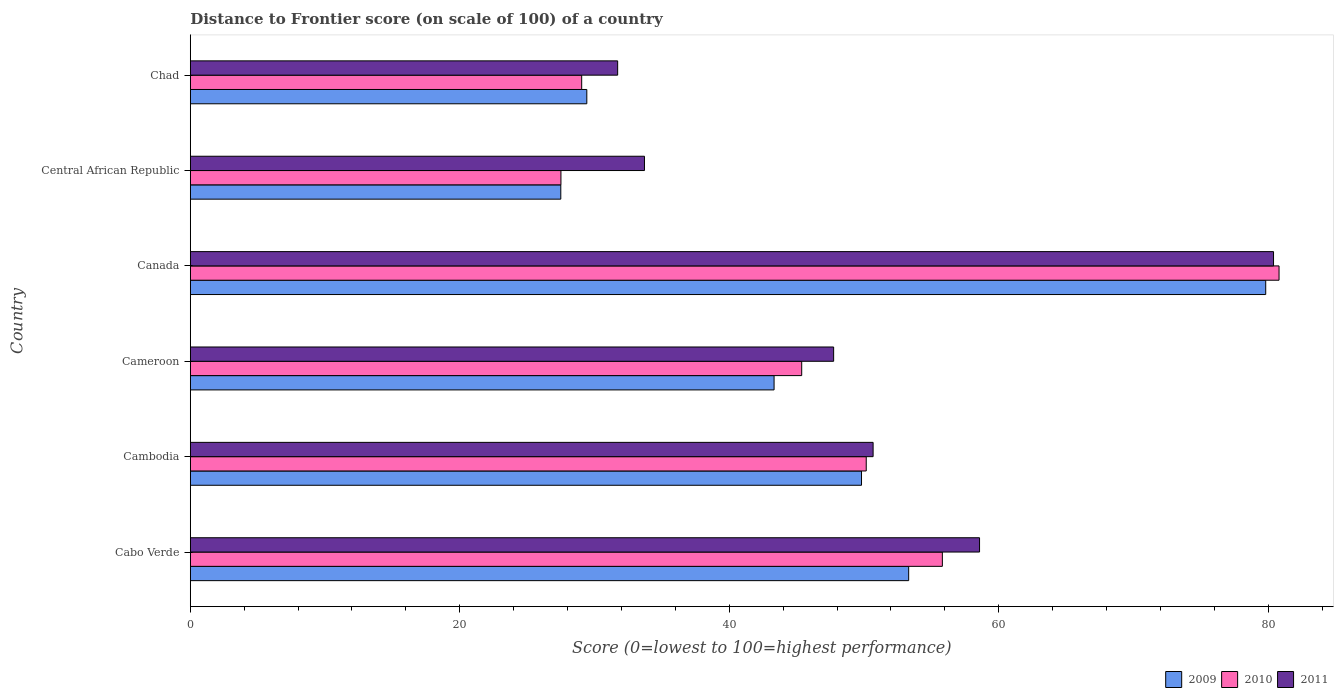How many different coloured bars are there?
Provide a short and direct response. 3. Are the number of bars per tick equal to the number of legend labels?
Give a very brief answer. Yes. How many bars are there on the 1st tick from the top?
Your answer should be compact. 3. How many bars are there on the 4th tick from the bottom?
Your response must be concise. 3. What is the label of the 6th group of bars from the top?
Your response must be concise. Cabo Verde. What is the distance to frontier score of in 2010 in Canada?
Your answer should be very brief. 80.81. Across all countries, what is the maximum distance to frontier score of in 2009?
Make the answer very short. 79.82. In which country was the distance to frontier score of in 2010 minimum?
Offer a terse response. Central African Republic. What is the total distance to frontier score of in 2011 in the graph?
Make the answer very short. 302.84. What is the difference between the distance to frontier score of in 2010 in Canada and that in Central African Republic?
Your response must be concise. 53.3. What is the difference between the distance to frontier score of in 2011 in Canada and the distance to frontier score of in 2010 in Chad?
Offer a very short reply. 51.35. What is the average distance to frontier score of in 2010 per country?
Give a very brief answer. 48.12. What is the difference between the distance to frontier score of in 2011 and distance to frontier score of in 2010 in Canada?
Offer a terse response. -0.41. What is the ratio of the distance to frontier score of in 2011 in Cameroon to that in Canada?
Offer a very short reply. 0.59. Is the distance to frontier score of in 2010 in Canada less than that in Central African Republic?
Keep it short and to the point. No. Is the difference between the distance to frontier score of in 2011 in Cabo Verde and Central African Republic greater than the difference between the distance to frontier score of in 2010 in Cabo Verde and Central African Republic?
Offer a very short reply. No. What is the difference between the highest and the second highest distance to frontier score of in 2011?
Your answer should be compact. 21.82. What is the difference between the highest and the lowest distance to frontier score of in 2010?
Ensure brevity in your answer.  53.3. What does the 3rd bar from the bottom in Canada represents?
Offer a terse response. 2011. Is it the case that in every country, the sum of the distance to frontier score of in 2011 and distance to frontier score of in 2009 is greater than the distance to frontier score of in 2010?
Your response must be concise. Yes. Does the graph contain grids?
Your answer should be very brief. No. Where does the legend appear in the graph?
Your answer should be very brief. Bottom right. What is the title of the graph?
Offer a very short reply. Distance to Frontier score (on scale of 100) of a country. Does "2005" appear as one of the legend labels in the graph?
Your answer should be very brief. No. What is the label or title of the X-axis?
Your response must be concise. Score (0=lowest to 100=highest performance). What is the label or title of the Y-axis?
Your response must be concise. Country. What is the Score (0=lowest to 100=highest performance) in 2009 in Cabo Verde?
Your answer should be compact. 53.32. What is the Score (0=lowest to 100=highest performance) of 2010 in Cabo Verde?
Provide a succinct answer. 55.82. What is the Score (0=lowest to 100=highest performance) of 2011 in Cabo Verde?
Provide a succinct answer. 58.58. What is the Score (0=lowest to 100=highest performance) of 2009 in Cambodia?
Offer a terse response. 49.82. What is the Score (0=lowest to 100=highest performance) of 2010 in Cambodia?
Your answer should be compact. 50.17. What is the Score (0=lowest to 100=highest performance) in 2011 in Cambodia?
Your answer should be very brief. 50.68. What is the Score (0=lowest to 100=highest performance) in 2009 in Cameroon?
Ensure brevity in your answer.  43.33. What is the Score (0=lowest to 100=highest performance) in 2010 in Cameroon?
Offer a very short reply. 45.38. What is the Score (0=lowest to 100=highest performance) in 2011 in Cameroon?
Provide a short and direct response. 47.75. What is the Score (0=lowest to 100=highest performance) of 2009 in Canada?
Your answer should be compact. 79.82. What is the Score (0=lowest to 100=highest performance) in 2010 in Canada?
Your response must be concise. 80.81. What is the Score (0=lowest to 100=highest performance) of 2011 in Canada?
Your answer should be compact. 80.4. What is the Score (0=lowest to 100=highest performance) of 2010 in Central African Republic?
Offer a terse response. 27.51. What is the Score (0=lowest to 100=highest performance) of 2011 in Central African Republic?
Ensure brevity in your answer.  33.71. What is the Score (0=lowest to 100=highest performance) of 2009 in Chad?
Your answer should be very brief. 29.43. What is the Score (0=lowest to 100=highest performance) of 2010 in Chad?
Offer a terse response. 29.05. What is the Score (0=lowest to 100=highest performance) in 2011 in Chad?
Ensure brevity in your answer.  31.72. Across all countries, what is the maximum Score (0=lowest to 100=highest performance) of 2009?
Your answer should be very brief. 79.82. Across all countries, what is the maximum Score (0=lowest to 100=highest performance) of 2010?
Provide a succinct answer. 80.81. Across all countries, what is the maximum Score (0=lowest to 100=highest performance) in 2011?
Provide a succinct answer. 80.4. Across all countries, what is the minimum Score (0=lowest to 100=highest performance) in 2009?
Provide a succinct answer. 27.5. Across all countries, what is the minimum Score (0=lowest to 100=highest performance) of 2010?
Make the answer very short. 27.51. Across all countries, what is the minimum Score (0=lowest to 100=highest performance) of 2011?
Provide a succinct answer. 31.72. What is the total Score (0=lowest to 100=highest performance) of 2009 in the graph?
Give a very brief answer. 283.22. What is the total Score (0=lowest to 100=highest performance) in 2010 in the graph?
Keep it short and to the point. 288.74. What is the total Score (0=lowest to 100=highest performance) of 2011 in the graph?
Your answer should be very brief. 302.84. What is the difference between the Score (0=lowest to 100=highest performance) in 2010 in Cabo Verde and that in Cambodia?
Your answer should be very brief. 5.65. What is the difference between the Score (0=lowest to 100=highest performance) of 2011 in Cabo Verde and that in Cambodia?
Provide a short and direct response. 7.9. What is the difference between the Score (0=lowest to 100=highest performance) of 2009 in Cabo Verde and that in Cameroon?
Your answer should be very brief. 9.99. What is the difference between the Score (0=lowest to 100=highest performance) in 2010 in Cabo Verde and that in Cameroon?
Your answer should be compact. 10.44. What is the difference between the Score (0=lowest to 100=highest performance) in 2011 in Cabo Verde and that in Cameroon?
Your answer should be compact. 10.83. What is the difference between the Score (0=lowest to 100=highest performance) of 2009 in Cabo Verde and that in Canada?
Give a very brief answer. -26.5. What is the difference between the Score (0=lowest to 100=highest performance) in 2010 in Cabo Verde and that in Canada?
Keep it short and to the point. -24.99. What is the difference between the Score (0=lowest to 100=highest performance) of 2011 in Cabo Verde and that in Canada?
Keep it short and to the point. -21.82. What is the difference between the Score (0=lowest to 100=highest performance) in 2009 in Cabo Verde and that in Central African Republic?
Make the answer very short. 25.82. What is the difference between the Score (0=lowest to 100=highest performance) in 2010 in Cabo Verde and that in Central African Republic?
Provide a succinct answer. 28.31. What is the difference between the Score (0=lowest to 100=highest performance) of 2011 in Cabo Verde and that in Central African Republic?
Your answer should be very brief. 24.87. What is the difference between the Score (0=lowest to 100=highest performance) in 2009 in Cabo Verde and that in Chad?
Provide a succinct answer. 23.89. What is the difference between the Score (0=lowest to 100=highest performance) in 2010 in Cabo Verde and that in Chad?
Give a very brief answer. 26.77. What is the difference between the Score (0=lowest to 100=highest performance) in 2011 in Cabo Verde and that in Chad?
Your answer should be very brief. 26.86. What is the difference between the Score (0=lowest to 100=highest performance) in 2009 in Cambodia and that in Cameroon?
Your answer should be compact. 6.49. What is the difference between the Score (0=lowest to 100=highest performance) in 2010 in Cambodia and that in Cameroon?
Your answer should be compact. 4.79. What is the difference between the Score (0=lowest to 100=highest performance) of 2011 in Cambodia and that in Cameroon?
Provide a succinct answer. 2.93. What is the difference between the Score (0=lowest to 100=highest performance) in 2009 in Cambodia and that in Canada?
Keep it short and to the point. -30. What is the difference between the Score (0=lowest to 100=highest performance) of 2010 in Cambodia and that in Canada?
Make the answer very short. -30.64. What is the difference between the Score (0=lowest to 100=highest performance) of 2011 in Cambodia and that in Canada?
Make the answer very short. -29.72. What is the difference between the Score (0=lowest to 100=highest performance) in 2009 in Cambodia and that in Central African Republic?
Offer a very short reply. 22.32. What is the difference between the Score (0=lowest to 100=highest performance) in 2010 in Cambodia and that in Central African Republic?
Provide a succinct answer. 22.66. What is the difference between the Score (0=lowest to 100=highest performance) in 2011 in Cambodia and that in Central African Republic?
Your answer should be compact. 16.97. What is the difference between the Score (0=lowest to 100=highest performance) of 2009 in Cambodia and that in Chad?
Offer a very short reply. 20.39. What is the difference between the Score (0=lowest to 100=highest performance) in 2010 in Cambodia and that in Chad?
Give a very brief answer. 21.12. What is the difference between the Score (0=lowest to 100=highest performance) of 2011 in Cambodia and that in Chad?
Offer a terse response. 18.96. What is the difference between the Score (0=lowest to 100=highest performance) in 2009 in Cameroon and that in Canada?
Your answer should be very brief. -36.49. What is the difference between the Score (0=lowest to 100=highest performance) of 2010 in Cameroon and that in Canada?
Ensure brevity in your answer.  -35.43. What is the difference between the Score (0=lowest to 100=highest performance) of 2011 in Cameroon and that in Canada?
Keep it short and to the point. -32.65. What is the difference between the Score (0=lowest to 100=highest performance) of 2009 in Cameroon and that in Central African Republic?
Your answer should be very brief. 15.83. What is the difference between the Score (0=lowest to 100=highest performance) of 2010 in Cameroon and that in Central African Republic?
Offer a terse response. 17.87. What is the difference between the Score (0=lowest to 100=highest performance) of 2011 in Cameroon and that in Central African Republic?
Make the answer very short. 14.04. What is the difference between the Score (0=lowest to 100=highest performance) of 2010 in Cameroon and that in Chad?
Keep it short and to the point. 16.33. What is the difference between the Score (0=lowest to 100=highest performance) of 2011 in Cameroon and that in Chad?
Your answer should be compact. 16.03. What is the difference between the Score (0=lowest to 100=highest performance) in 2009 in Canada and that in Central African Republic?
Your answer should be compact. 52.32. What is the difference between the Score (0=lowest to 100=highest performance) of 2010 in Canada and that in Central African Republic?
Keep it short and to the point. 53.3. What is the difference between the Score (0=lowest to 100=highest performance) in 2011 in Canada and that in Central African Republic?
Make the answer very short. 46.69. What is the difference between the Score (0=lowest to 100=highest performance) of 2009 in Canada and that in Chad?
Your response must be concise. 50.39. What is the difference between the Score (0=lowest to 100=highest performance) of 2010 in Canada and that in Chad?
Your response must be concise. 51.76. What is the difference between the Score (0=lowest to 100=highest performance) in 2011 in Canada and that in Chad?
Your answer should be compact. 48.68. What is the difference between the Score (0=lowest to 100=highest performance) of 2009 in Central African Republic and that in Chad?
Ensure brevity in your answer.  -1.93. What is the difference between the Score (0=lowest to 100=highest performance) in 2010 in Central African Republic and that in Chad?
Your answer should be very brief. -1.54. What is the difference between the Score (0=lowest to 100=highest performance) of 2011 in Central African Republic and that in Chad?
Provide a short and direct response. 1.99. What is the difference between the Score (0=lowest to 100=highest performance) in 2009 in Cabo Verde and the Score (0=lowest to 100=highest performance) in 2010 in Cambodia?
Give a very brief answer. 3.15. What is the difference between the Score (0=lowest to 100=highest performance) of 2009 in Cabo Verde and the Score (0=lowest to 100=highest performance) of 2011 in Cambodia?
Ensure brevity in your answer.  2.64. What is the difference between the Score (0=lowest to 100=highest performance) of 2010 in Cabo Verde and the Score (0=lowest to 100=highest performance) of 2011 in Cambodia?
Offer a terse response. 5.14. What is the difference between the Score (0=lowest to 100=highest performance) of 2009 in Cabo Verde and the Score (0=lowest to 100=highest performance) of 2010 in Cameroon?
Your answer should be very brief. 7.94. What is the difference between the Score (0=lowest to 100=highest performance) of 2009 in Cabo Verde and the Score (0=lowest to 100=highest performance) of 2011 in Cameroon?
Give a very brief answer. 5.57. What is the difference between the Score (0=lowest to 100=highest performance) of 2010 in Cabo Verde and the Score (0=lowest to 100=highest performance) of 2011 in Cameroon?
Offer a very short reply. 8.07. What is the difference between the Score (0=lowest to 100=highest performance) of 2009 in Cabo Verde and the Score (0=lowest to 100=highest performance) of 2010 in Canada?
Offer a very short reply. -27.49. What is the difference between the Score (0=lowest to 100=highest performance) of 2009 in Cabo Verde and the Score (0=lowest to 100=highest performance) of 2011 in Canada?
Provide a short and direct response. -27.08. What is the difference between the Score (0=lowest to 100=highest performance) of 2010 in Cabo Verde and the Score (0=lowest to 100=highest performance) of 2011 in Canada?
Your answer should be very brief. -24.58. What is the difference between the Score (0=lowest to 100=highest performance) in 2009 in Cabo Verde and the Score (0=lowest to 100=highest performance) in 2010 in Central African Republic?
Your answer should be compact. 25.81. What is the difference between the Score (0=lowest to 100=highest performance) of 2009 in Cabo Verde and the Score (0=lowest to 100=highest performance) of 2011 in Central African Republic?
Make the answer very short. 19.61. What is the difference between the Score (0=lowest to 100=highest performance) in 2010 in Cabo Verde and the Score (0=lowest to 100=highest performance) in 2011 in Central African Republic?
Ensure brevity in your answer.  22.11. What is the difference between the Score (0=lowest to 100=highest performance) in 2009 in Cabo Verde and the Score (0=lowest to 100=highest performance) in 2010 in Chad?
Offer a very short reply. 24.27. What is the difference between the Score (0=lowest to 100=highest performance) of 2009 in Cabo Verde and the Score (0=lowest to 100=highest performance) of 2011 in Chad?
Give a very brief answer. 21.6. What is the difference between the Score (0=lowest to 100=highest performance) of 2010 in Cabo Verde and the Score (0=lowest to 100=highest performance) of 2011 in Chad?
Provide a succinct answer. 24.1. What is the difference between the Score (0=lowest to 100=highest performance) in 2009 in Cambodia and the Score (0=lowest to 100=highest performance) in 2010 in Cameroon?
Your answer should be compact. 4.44. What is the difference between the Score (0=lowest to 100=highest performance) in 2009 in Cambodia and the Score (0=lowest to 100=highest performance) in 2011 in Cameroon?
Keep it short and to the point. 2.07. What is the difference between the Score (0=lowest to 100=highest performance) of 2010 in Cambodia and the Score (0=lowest to 100=highest performance) of 2011 in Cameroon?
Offer a very short reply. 2.42. What is the difference between the Score (0=lowest to 100=highest performance) in 2009 in Cambodia and the Score (0=lowest to 100=highest performance) in 2010 in Canada?
Your response must be concise. -30.99. What is the difference between the Score (0=lowest to 100=highest performance) of 2009 in Cambodia and the Score (0=lowest to 100=highest performance) of 2011 in Canada?
Give a very brief answer. -30.58. What is the difference between the Score (0=lowest to 100=highest performance) in 2010 in Cambodia and the Score (0=lowest to 100=highest performance) in 2011 in Canada?
Provide a short and direct response. -30.23. What is the difference between the Score (0=lowest to 100=highest performance) of 2009 in Cambodia and the Score (0=lowest to 100=highest performance) of 2010 in Central African Republic?
Provide a succinct answer. 22.31. What is the difference between the Score (0=lowest to 100=highest performance) of 2009 in Cambodia and the Score (0=lowest to 100=highest performance) of 2011 in Central African Republic?
Offer a terse response. 16.11. What is the difference between the Score (0=lowest to 100=highest performance) in 2010 in Cambodia and the Score (0=lowest to 100=highest performance) in 2011 in Central African Republic?
Offer a very short reply. 16.46. What is the difference between the Score (0=lowest to 100=highest performance) in 2009 in Cambodia and the Score (0=lowest to 100=highest performance) in 2010 in Chad?
Provide a short and direct response. 20.77. What is the difference between the Score (0=lowest to 100=highest performance) in 2009 in Cambodia and the Score (0=lowest to 100=highest performance) in 2011 in Chad?
Offer a very short reply. 18.1. What is the difference between the Score (0=lowest to 100=highest performance) in 2010 in Cambodia and the Score (0=lowest to 100=highest performance) in 2011 in Chad?
Provide a succinct answer. 18.45. What is the difference between the Score (0=lowest to 100=highest performance) in 2009 in Cameroon and the Score (0=lowest to 100=highest performance) in 2010 in Canada?
Keep it short and to the point. -37.48. What is the difference between the Score (0=lowest to 100=highest performance) in 2009 in Cameroon and the Score (0=lowest to 100=highest performance) in 2011 in Canada?
Provide a short and direct response. -37.07. What is the difference between the Score (0=lowest to 100=highest performance) of 2010 in Cameroon and the Score (0=lowest to 100=highest performance) of 2011 in Canada?
Provide a short and direct response. -35.02. What is the difference between the Score (0=lowest to 100=highest performance) in 2009 in Cameroon and the Score (0=lowest to 100=highest performance) in 2010 in Central African Republic?
Keep it short and to the point. 15.82. What is the difference between the Score (0=lowest to 100=highest performance) of 2009 in Cameroon and the Score (0=lowest to 100=highest performance) of 2011 in Central African Republic?
Your answer should be very brief. 9.62. What is the difference between the Score (0=lowest to 100=highest performance) in 2010 in Cameroon and the Score (0=lowest to 100=highest performance) in 2011 in Central African Republic?
Keep it short and to the point. 11.67. What is the difference between the Score (0=lowest to 100=highest performance) in 2009 in Cameroon and the Score (0=lowest to 100=highest performance) in 2010 in Chad?
Offer a terse response. 14.28. What is the difference between the Score (0=lowest to 100=highest performance) in 2009 in Cameroon and the Score (0=lowest to 100=highest performance) in 2011 in Chad?
Offer a terse response. 11.61. What is the difference between the Score (0=lowest to 100=highest performance) of 2010 in Cameroon and the Score (0=lowest to 100=highest performance) of 2011 in Chad?
Provide a succinct answer. 13.66. What is the difference between the Score (0=lowest to 100=highest performance) in 2009 in Canada and the Score (0=lowest to 100=highest performance) in 2010 in Central African Republic?
Make the answer very short. 52.31. What is the difference between the Score (0=lowest to 100=highest performance) of 2009 in Canada and the Score (0=lowest to 100=highest performance) of 2011 in Central African Republic?
Ensure brevity in your answer.  46.11. What is the difference between the Score (0=lowest to 100=highest performance) in 2010 in Canada and the Score (0=lowest to 100=highest performance) in 2011 in Central African Republic?
Keep it short and to the point. 47.1. What is the difference between the Score (0=lowest to 100=highest performance) in 2009 in Canada and the Score (0=lowest to 100=highest performance) in 2010 in Chad?
Provide a succinct answer. 50.77. What is the difference between the Score (0=lowest to 100=highest performance) of 2009 in Canada and the Score (0=lowest to 100=highest performance) of 2011 in Chad?
Give a very brief answer. 48.1. What is the difference between the Score (0=lowest to 100=highest performance) of 2010 in Canada and the Score (0=lowest to 100=highest performance) of 2011 in Chad?
Offer a terse response. 49.09. What is the difference between the Score (0=lowest to 100=highest performance) in 2009 in Central African Republic and the Score (0=lowest to 100=highest performance) in 2010 in Chad?
Give a very brief answer. -1.55. What is the difference between the Score (0=lowest to 100=highest performance) in 2009 in Central African Republic and the Score (0=lowest to 100=highest performance) in 2011 in Chad?
Offer a terse response. -4.22. What is the difference between the Score (0=lowest to 100=highest performance) of 2010 in Central African Republic and the Score (0=lowest to 100=highest performance) of 2011 in Chad?
Offer a terse response. -4.21. What is the average Score (0=lowest to 100=highest performance) of 2009 per country?
Your answer should be compact. 47.2. What is the average Score (0=lowest to 100=highest performance) in 2010 per country?
Your answer should be compact. 48.12. What is the average Score (0=lowest to 100=highest performance) of 2011 per country?
Offer a very short reply. 50.47. What is the difference between the Score (0=lowest to 100=highest performance) of 2009 and Score (0=lowest to 100=highest performance) of 2011 in Cabo Verde?
Offer a terse response. -5.26. What is the difference between the Score (0=lowest to 100=highest performance) of 2010 and Score (0=lowest to 100=highest performance) of 2011 in Cabo Verde?
Your answer should be very brief. -2.76. What is the difference between the Score (0=lowest to 100=highest performance) of 2009 and Score (0=lowest to 100=highest performance) of 2010 in Cambodia?
Your answer should be compact. -0.35. What is the difference between the Score (0=lowest to 100=highest performance) in 2009 and Score (0=lowest to 100=highest performance) in 2011 in Cambodia?
Make the answer very short. -0.86. What is the difference between the Score (0=lowest to 100=highest performance) of 2010 and Score (0=lowest to 100=highest performance) of 2011 in Cambodia?
Your answer should be very brief. -0.51. What is the difference between the Score (0=lowest to 100=highest performance) of 2009 and Score (0=lowest to 100=highest performance) of 2010 in Cameroon?
Offer a very short reply. -2.05. What is the difference between the Score (0=lowest to 100=highest performance) in 2009 and Score (0=lowest to 100=highest performance) in 2011 in Cameroon?
Provide a succinct answer. -4.42. What is the difference between the Score (0=lowest to 100=highest performance) of 2010 and Score (0=lowest to 100=highest performance) of 2011 in Cameroon?
Your response must be concise. -2.37. What is the difference between the Score (0=lowest to 100=highest performance) of 2009 and Score (0=lowest to 100=highest performance) of 2010 in Canada?
Offer a very short reply. -0.99. What is the difference between the Score (0=lowest to 100=highest performance) of 2009 and Score (0=lowest to 100=highest performance) of 2011 in Canada?
Ensure brevity in your answer.  -0.58. What is the difference between the Score (0=lowest to 100=highest performance) of 2010 and Score (0=lowest to 100=highest performance) of 2011 in Canada?
Offer a terse response. 0.41. What is the difference between the Score (0=lowest to 100=highest performance) in 2009 and Score (0=lowest to 100=highest performance) in 2010 in Central African Republic?
Ensure brevity in your answer.  -0.01. What is the difference between the Score (0=lowest to 100=highest performance) in 2009 and Score (0=lowest to 100=highest performance) in 2011 in Central African Republic?
Your answer should be very brief. -6.21. What is the difference between the Score (0=lowest to 100=highest performance) in 2010 and Score (0=lowest to 100=highest performance) in 2011 in Central African Republic?
Provide a short and direct response. -6.2. What is the difference between the Score (0=lowest to 100=highest performance) in 2009 and Score (0=lowest to 100=highest performance) in 2010 in Chad?
Your response must be concise. 0.38. What is the difference between the Score (0=lowest to 100=highest performance) of 2009 and Score (0=lowest to 100=highest performance) of 2011 in Chad?
Provide a short and direct response. -2.29. What is the difference between the Score (0=lowest to 100=highest performance) of 2010 and Score (0=lowest to 100=highest performance) of 2011 in Chad?
Provide a succinct answer. -2.67. What is the ratio of the Score (0=lowest to 100=highest performance) in 2009 in Cabo Verde to that in Cambodia?
Ensure brevity in your answer.  1.07. What is the ratio of the Score (0=lowest to 100=highest performance) of 2010 in Cabo Verde to that in Cambodia?
Your answer should be compact. 1.11. What is the ratio of the Score (0=lowest to 100=highest performance) in 2011 in Cabo Verde to that in Cambodia?
Offer a terse response. 1.16. What is the ratio of the Score (0=lowest to 100=highest performance) in 2009 in Cabo Verde to that in Cameroon?
Provide a succinct answer. 1.23. What is the ratio of the Score (0=lowest to 100=highest performance) in 2010 in Cabo Verde to that in Cameroon?
Provide a short and direct response. 1.23. What is the ratio of the Score (0=lowest to 100=highest performance) in 2011 in Cabo Verde to that in Cameroon?
Make the answer very short. 1.23. What is the ratio of the Score (0=lowest to 100=highest performance) in 2009 in Cabo Verde to that in Canada?
Offer a very short reply. 0.67. What is the ratio of the Score (0=lowest to 100=highest performance) of 2010 in Cabo Verde to that in Canada?
Offer a terse response. 0.69. What is the ratio of the Score (0=lowest to 100=highest performance) of 2011 in Cabo Verde to that in Canada?
Provide a succinct answer. 0.73. What is the ratio of the Score (0=lowest to 100=highest performance) in 2009 in Cabo Verde to that in Central African Republic?
Ensure brevity in your answer.  1.94. What is the ratio of the Score (0=lowest to 100=highest performance) of 2010 in Cabo Verde to that in Central African Republic?
Offer a very short reply. 2.03. What is the ratio of the Score (0=lowest to 100=highest performance) in 2011 in Cabo Verde to that in Central African Republic?
Offer a very short reply. 1.74. What is the ratio of the Score (0=lowest to 100=highest performance) in 2009 in Cabo Verde to that in Chad?
Ensure brevity in your answer.  1.81. What is the ratio of the Score (0=lowest to 100=highest performance) in 2010 in Cabo Verde to that in Chad?
Provide a succinct answer. 1.92. What is the ratio of the Score (0=lowest to 100=highest performance) of 2011 in Cabo Verde to that in Chad?
Keep it short and to the point. 1.85. What is the ratio of the Score (0=lowest to 100=highest performance) of 2009 in Cambodia to that in Cameroon?
Your response must be concise. 1.15. What is the ratio of the Score (0=lowest to 100=highest performance) of 2010 in Cambodia to that in Cameroon?
Offer a very short reply. 1.11. What is the ratio of the Score (0=lowest to 100=highest performance) of 2011 in Cambodia to that in Cameroon?
Offer a terse response. 1.06. What is the ratio of the Score (0=lowest to 100=highest performance) of 2009 in Cambodia to that in Canada?
Ensure brevity in your answer.  0.62. What is the ratio of the Score (0=lowest to 100=highest performance) in 2010 in Cambodia to that in Canada?
Keep it short and to the point. 0.62. What is the ratio of the Score (0=lowest to 100=highest performance) in 2011 in Cambodia to that in Canada?
Your answer should be very brief. 0.63. What is the ratio of the Score (0=lowest to 100=highest performance) in 2009 in Cambodia to that in Central African Republic?
Provide a succinct answer. 1.81. What is the ratio of the Score (0=lowest to 100=highest performance) of 2010 in Cambodia to that in Central African Republic?
Keep it short and to the point. 1.82. What is the ratio of the Score (0=lowest to 100=highest performance) in 2011 in Cambodia to that in Central African Republic?
Your response must be concise. 1.5. What is the ratio of the Score (0=lowest to 100=highest performance) in 2009 in Cambodia to that in Chad?
Make the answer very short. 1.69. What is the ratio of the Score (0=lowest to 100=highest performance) of 2010 in Cambodia to that in Chad?
Your response must be concise. 1.73. What is the ratio of the Score (0=lowest to 100=highest performance) in 2011 in Cambodia to that in Chad?
Offer a terse response. 1.6. What is the ratio of the Score (0=lowest to 100=highest performance) in 2009 in Cameroon to that in Canada?
Keep it short and to the point. 0.54. What is the ratio of the Score (0=lowest to 100=highest performance) in 2010 in Cameroon to that in Canada?
Make the answer very short. 0.56. What is the ratio of the Score (0=lowest to 100=highest performance) in 2011 in Cameroon to that in Canada?
Your answer should be very brief. 0.59. What is the ratio of the Score (0=lowest to 100=highest performance) in 2009 in Cameroon to that in Central African Republic?
Offer a terse response. 1.58. What is the ratio of the Score (0=lowest to 100=highest performance) of 2010 in Cameroon to that in Central African Republic?
Ensure brevity in your answer.  1.65. What is the ratio of the Score (0=lowest to 100=highest performance) in 2011 in Cameroon to that in Central African Republic?
Give a very brief answer. 1.42. What is the ratio of the Score (0=lowest to 100=highest performance) of 2009 in Cameroon to that in Chad?
Your response must be concise. 1.47. What is the ratio of the Score (0=lowest to 100=highest performance) in 2010 in Cameroon to that in Chad?
Ensure brevity in your answer.  1.56. What is the ratio of the Score (0=lowest to 100=highest performance) of 2011 in Cameroon to that in Chad?
Provide a succinct answer. 1.51. What is the ratio of the Score (0=lowest to 100=highest performance) in 2009 in Canada to that in Central African Republic?
Keep it short and to the point. 2.9. What is the ratio of the Score (0=lowest to 100=highest performance) of 2010 in Canada to that in Central African Republic?
Offer a very short reply. 2.94. What is the ratio of the Score (0=lowest to 100=highest performance) in 2011 in Canada to that in Central African Republic?
Provide a short and direct response. 2.38. What is the ratio of the Score (0=lowest to 100=highest performance) of 2009 in Canada to that in Chad?
Your answer should be compact. 2.71. What is the ratio of the Score (0=lowest to 100=highest performance) of 2010 in Canada to that in Chad?
Offer a terse response. 2.78. What is the ratio of the Score (0=lowest to 100=highest performance) in 2011 in Canada to that in Chad?
Your response must be concise. 2.53. What is the ratio of the Score (0=lowest to 100=highest performance) in 2009 in Central African Republic to that in Chad?
Provide a succinct answer. 0.93. What is the ratio of the Score (0=lowest to 100=highest performance) of 2010 in Central African Republic to that in Chad?
Ensure brevity in your answer.  0.95. What is the ratio of the Score (0=lowest to 100=highest performance) in 2011 in Central African Republic to that in Chad?
Provide a short and direct response. 1.06. What is the difference between the highest and the second highest Score (0=lowest to 100=highest performance) in 2010?
Offer a very short reply. 24.99. What is the difference between the highest and the second highest Score (0=lowest to 100=highest performance) in 2011?
Your response must be concise. 21.82. What is the difference between the highest and the lowest Score (0=lowest to 100=highest performance) in 2009?
Provide a succinct answer. 52.32. What is the difference between the highest and the lowest Score (0=lowest to 100=highest performance) in 2010?
Ensure brevity in your answer.  53.3. What is the difference between the highest and the lowest Score (0=lowest to 100=highest performance) in 2011?
Provide a succinct answer. 48.68. 